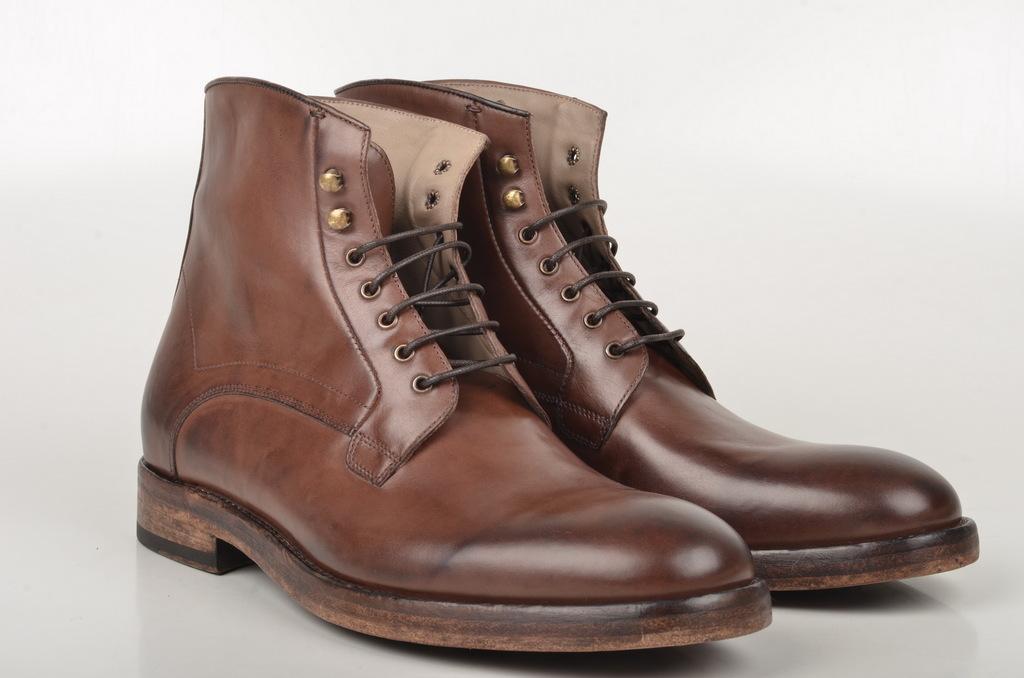Please provide a concise description of this image. In this picture we can see shoes on the platform. 